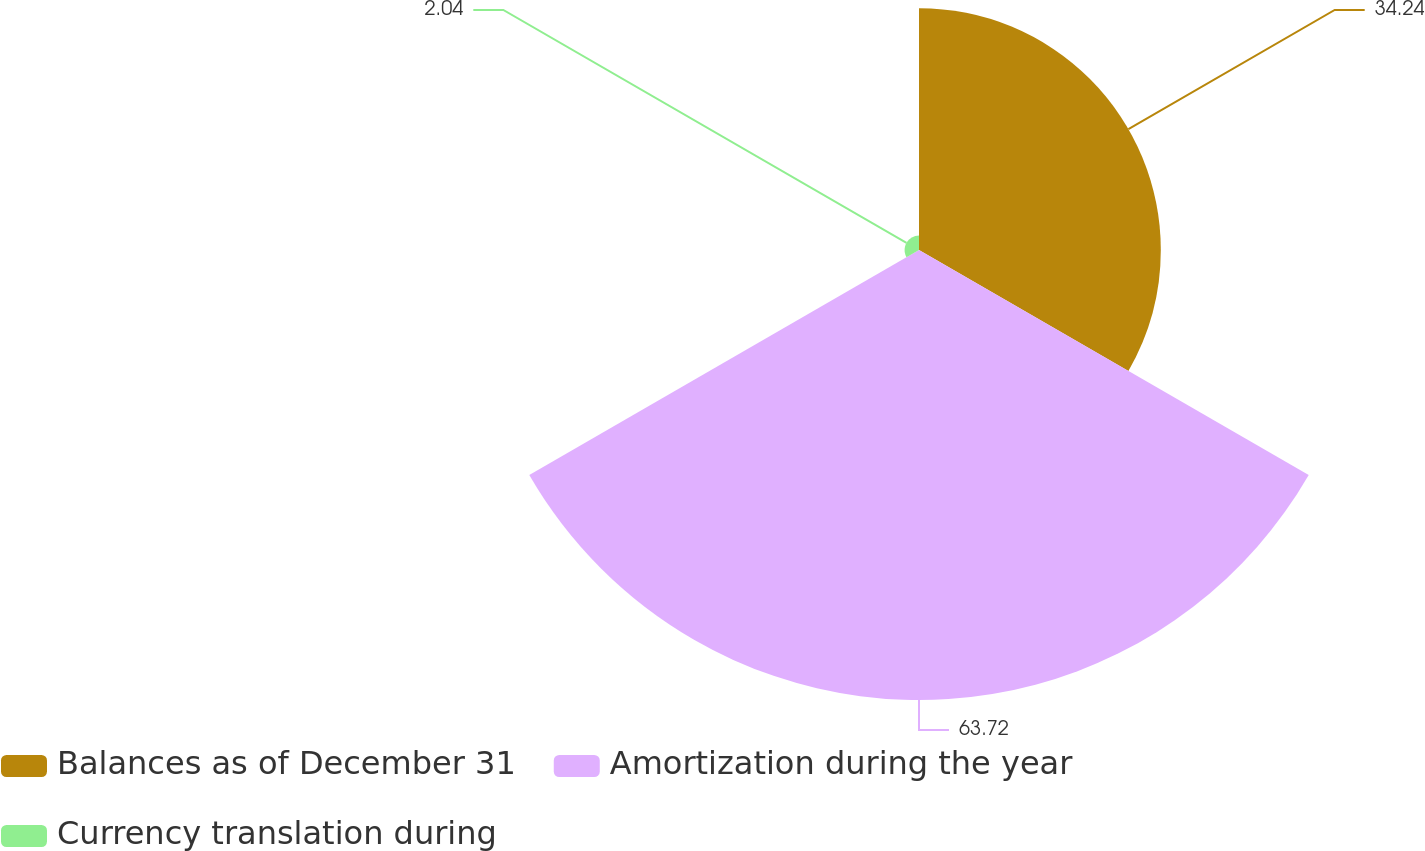Convert chart. <chart><loc_0><loc_0><loc_500><loc_500><pie_chart><fcel>Balances as of December 31<fcel>Amortization during the year<fcel>Currency translation during<nl><fcel>34.24%<fcel>63.72%<fcel>2.04%<nl></chart> 